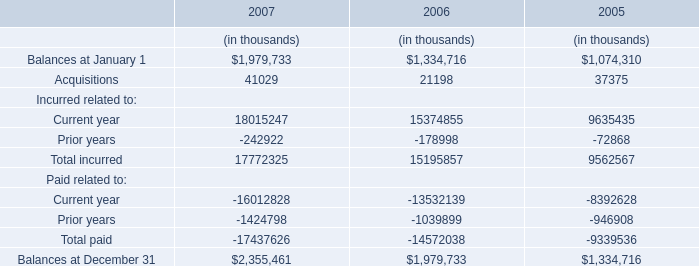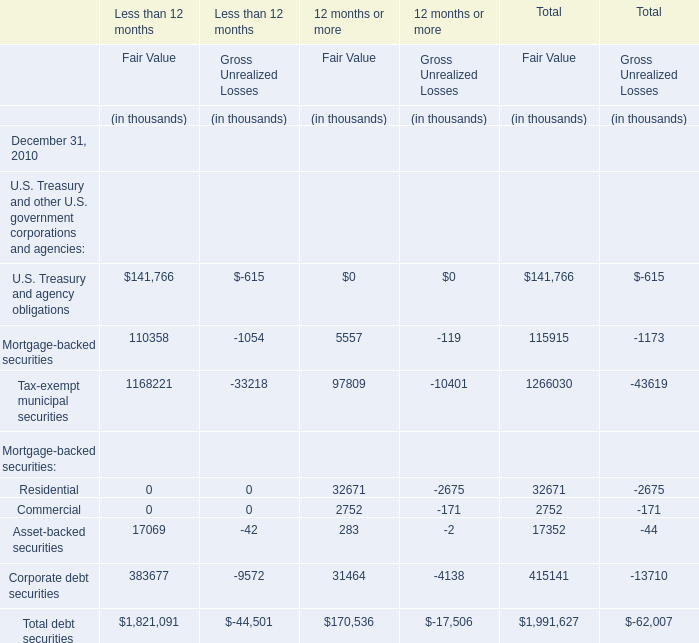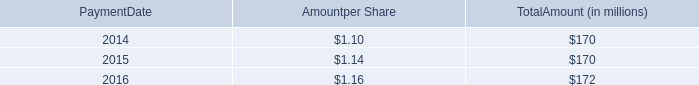what was the number of stockholders of record on january 12 , 2017 , for an aggregate amount of $ 43 million . 
Computations: (43 / 0.29)
Answer: 148.27586. 